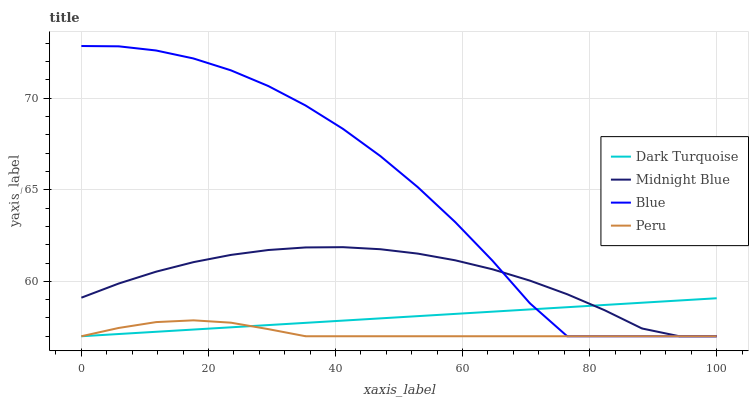Does Peru have the minimum area under the curve?
Answer yes or no. Yes. Does Blue have the maximum area under the curve?
Answer yes or no. Yes. Does Dark Turquoise have the minimum area under the curve?
Answer yes or no. No. Does Dark Turquoise have the maximum area under the curve?
Answer yes or no. No. Is Dark Turquoise the smoothest?
Answer yes or no. Yes. Is Blue the roughest?
Answer yes or no. Yes. Is Midnight Blue the smoothest?
Answer yes or no. No. Is Midnight Blue the roughest?
Answer yes or no. No. Does Blue have the lowest value?
Answer yes or no. Yes. Does Blue have the highest value?
Answer yes or no. Yes. Does Dark Turquoise have the highest value?
Answer yes or no. No. Does Midnight Blue intersect Dark Turquoise?
Answer yes or no. Yes. Is Midnight Blue less than Dark Turquoise?
Answer yes or no. No. Is Midnight Blue greater than Dark Turquoise?
Answer yes or no. No. 